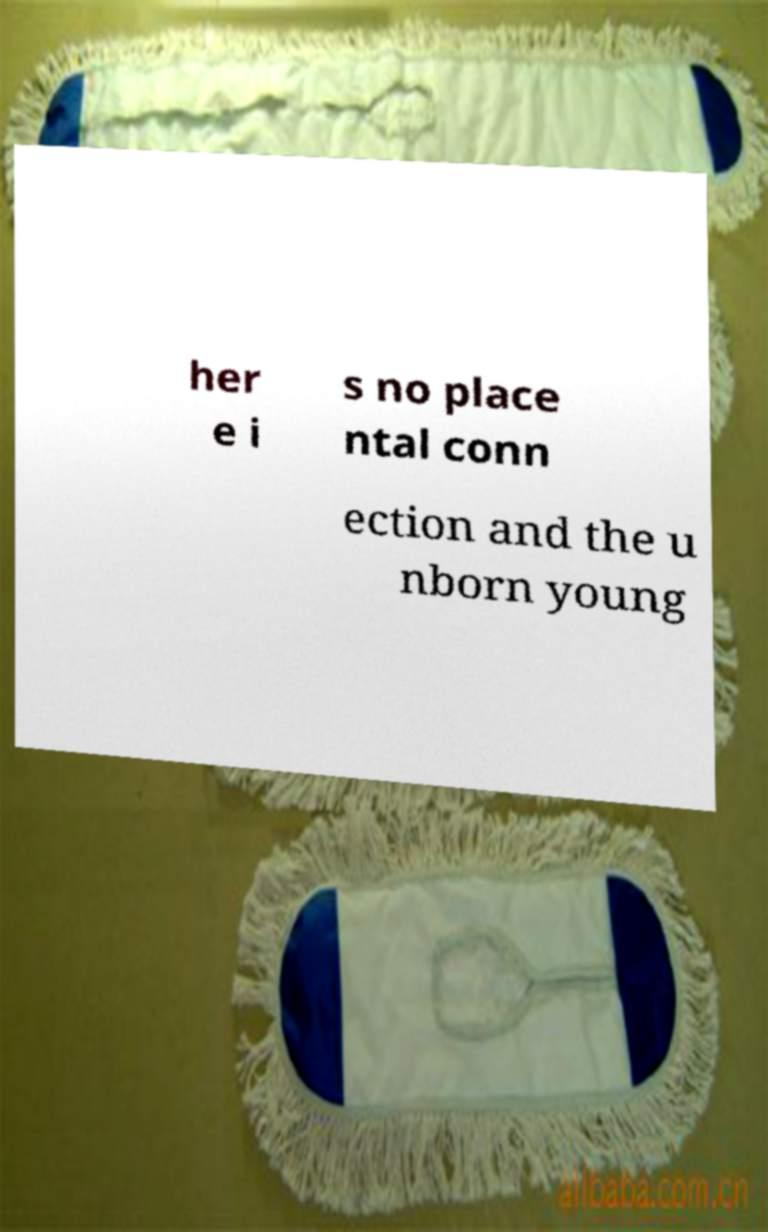Can you accurately transcribe the text from the provided image for me? her e i s no place ntal conn ection and the u nborn young 